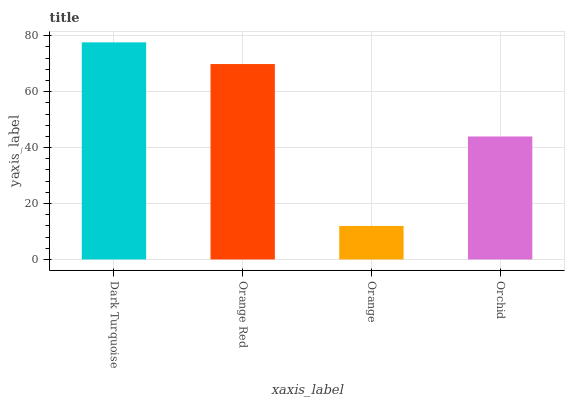Is Orange the minimum?
Answer yes or no. Yes. Is Dark Turquoise the maximum?
Answer yes or no. Yes. Is Orange Red the minimum?
Answer yes or no. No. Is Orange Red the maximum?
Answer yes or no. No. Is Dark Turquoise greater than Orange Red?
Answer yes or no. Yes. Is Orange Red less than Dark Turquoise?
Answer yes or no. Yes. Is Orange Red greater than Dark Turquoise?
Answer yes or no. No. Is Dark Turquoise less than Orange Red?
Answer yes or no. No. Is Orange Red the high median?
Answer yes or no. Yes. Is Orchid the low median?
Answer yes or no. Yes. Is Dark Turquoise the high median?
Answer yes or no. No. Is Orange Red the low median?
Answer yes or no. No. 